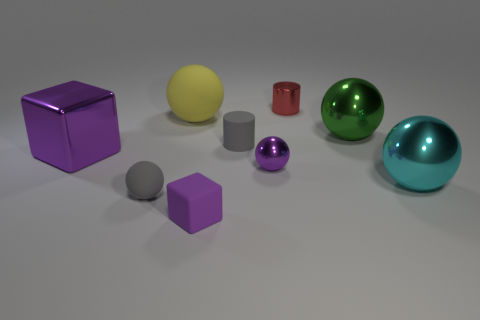Subtract all purple balls. How many balls are left? 4 Subtract all gray spheres. How many spheres are left? 4 Subtract all brown balls. Subtract all red cylinders. How many balls are left? 5 Add 1 cyan metallic things. How many objects exist? 10 Subtract all spheres. How many objects are left? 4 Add 1 yellow matte things. How many yellow matte things are left? 2 Add 4 big purple objects. How many big purple objects exist? 5 Subtract 0 gray blocks. How many objects are left? 9 Subtract all large purple shiny spheres. Subtract all small rubber cylinders. How many objects are left? 8 